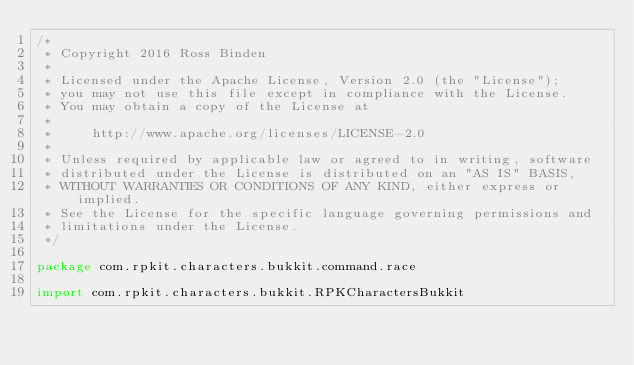<code> <loc_0><loc_0><loc_500><loc_500><_Kotlin_>/*
 * Copyright 2016 Ross Binden
 *
 * Licensed under the Apache License, Version 2.0 (the "License");
 * you may not use this file except in compliance with the License.
 * You may obtain a copy of the License at
 *
 *     http://www.apache.org/licenses/LICENSE-2.0
 *
 * Unless required by applicable law or agreed to in writing, software
 * distributed under the License is distributed on an "AS IS" BASIS,
 * WITHOUT WARRANTIES OR CONDITIONS OF ANY KIND, either express or implied.
 * See the License for the specific language governing permissions and
 * limitations under the License.
 */

package com.rpkit.characters.bukkit.command.race

import com.rpkit.characters.bukkit.RPKCharactersBukkit</code> 